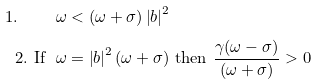<formula> <loc_0><loc_0><loc_500><loc_500>1 . \text { \quad } \omega & < ( \omega + \sigma ) \left | b \right | ^ { 2 } \\ 2 . \text { If \ } \omega & = \left | b \right | ^ { 2 } ( \omega + \sigma ) \text { then } \frac { \gamma ( \omega - \sigma ) } { ( \omega + \sigma ) } > 0</formula> 